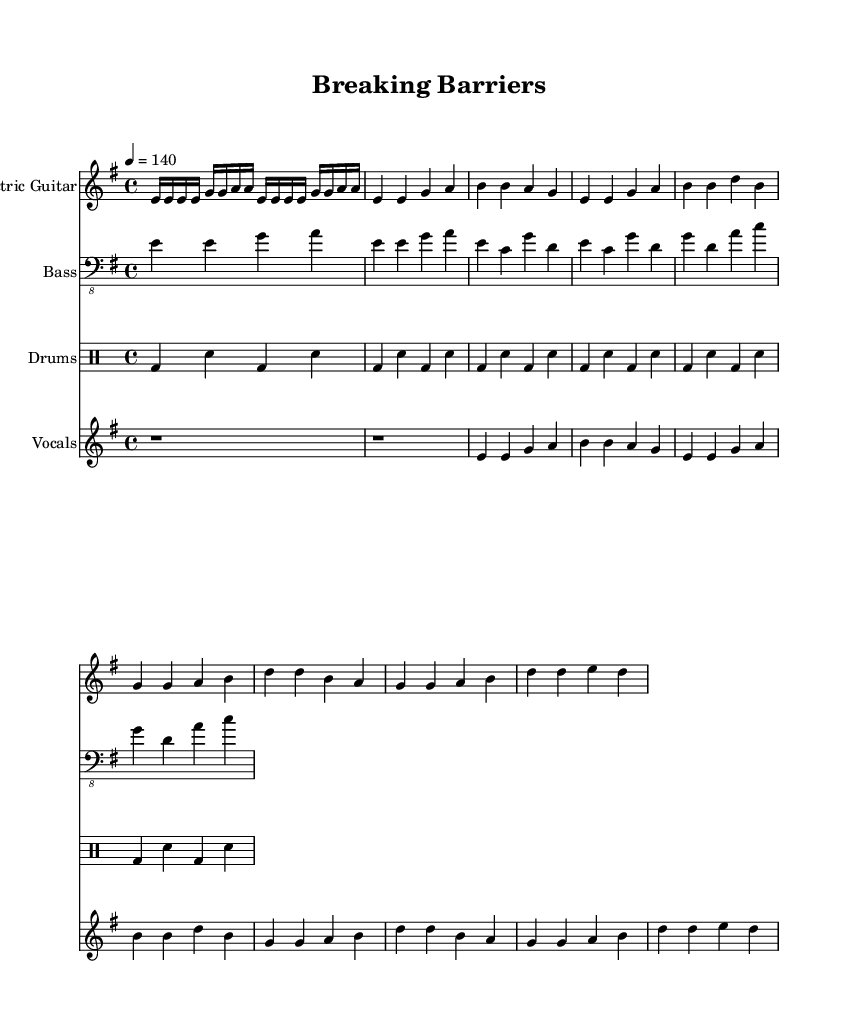What is the key signature of this music? The key signature appears at the beginning of the score. It indicates 1 sharp for F# and corresponds to E minor.
Answer: E minor What is the time signature of this music? The time signature is found at the beginning of the score. It is written as 4/4, which means there are 4 beats in a measure.
Answer: 4/4 What is the tempo marking of the piece? The tempo is indicated above the staff, showing a marking of 4 = 140, which means there are 140 quarter-note beats per minute.
Answer: 140 How many measures are in the verse section? Counting the measures in the “vocals” staff, there are a total of 8 measures comprising the verse section.
Answer: 8 What instrument plays the bass line? The instrumentation is specified within the staff header. The instrument designated for the bass line is "Bass."
Answer: Bass What is the lyrical theme of the chorus? Analyzing the lyrics provided under the vocal staff, the chorus focuses on empowerment and resilience in the face of challenges.
Answer: Empowerment How many times is the “e” note played in the first eight measures? By examining the “electric guitar” staff in the first eight measures, the “e” note appears four times, confirming it’s repeated throughout.
Answer: 4 